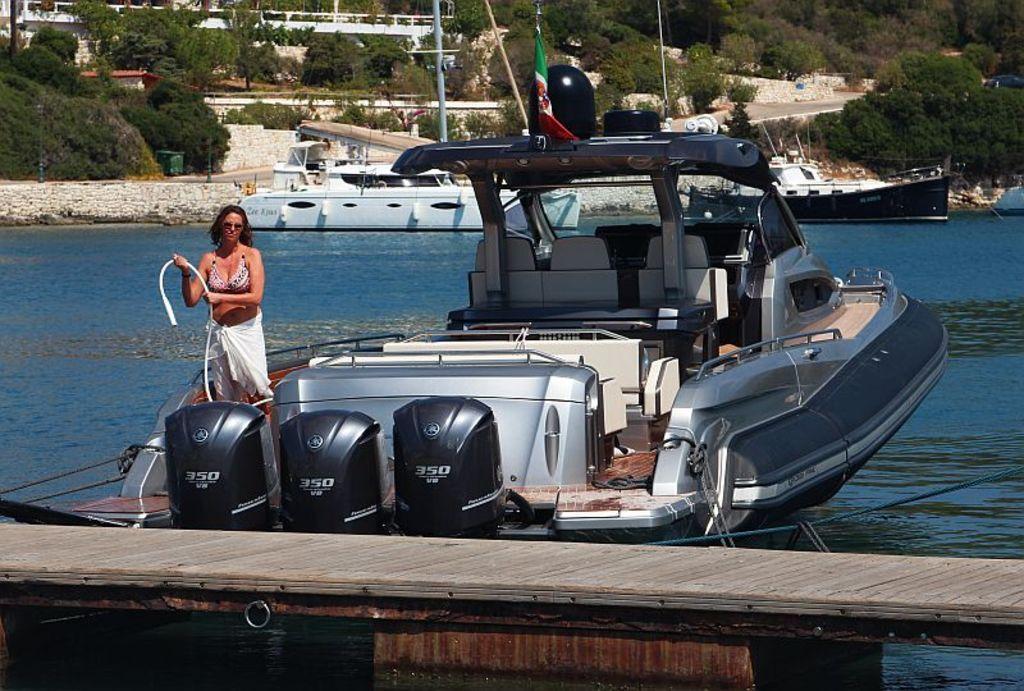In one or two sentences, can you explain what this image depicts? In this picture I can see the wooden platform in front and behind it I can see the water, on which I can see a boat, on which there is woman standing and holding a white color thing and on the boat I can see a flag. In the middle of this picture I can see the 2 more boats. In the background I can see number of trees and plants. 